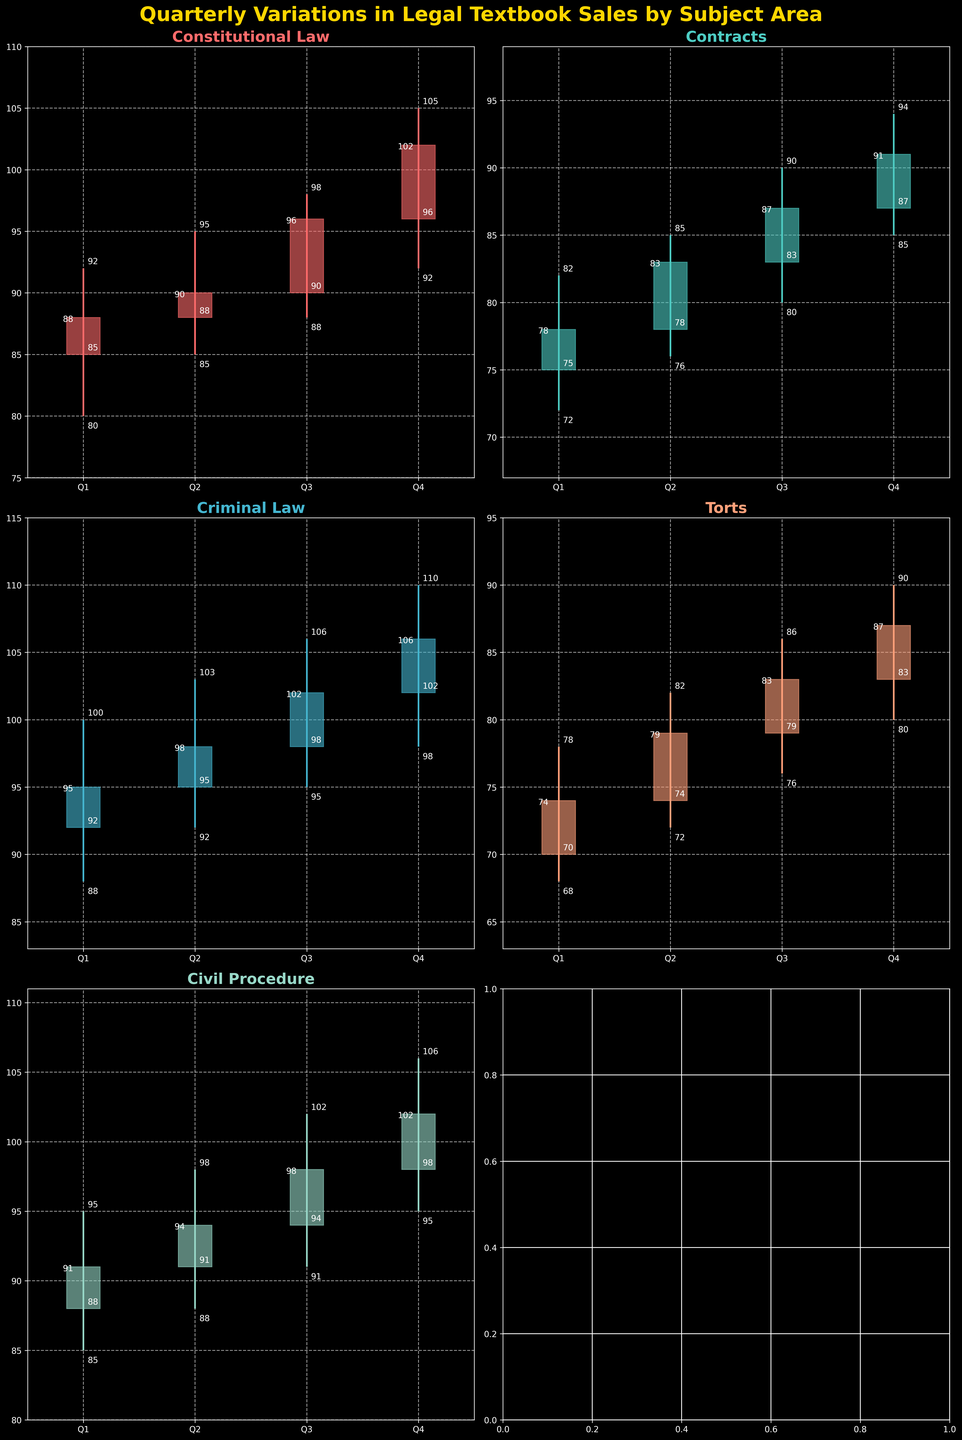Which subject area experienced the highest sales in Q4? The highest sales in Q4 can be identified by looking at the 'Close' values for each subject in Q4. The values are: Constitutional Law (102), Contracts (91), Criminal Law (106), Torts (87), Civil Procedure (102). The highest value is 106 for Criminal Law.
Answer: Criminal Law What was the lowest sales figure for Contracts throughout the year? The lowest sales figure for Contracts can be found by looking at the 'Low' values for each quarter. The values are: Q1 (72), Q2 (76), Q3 (80), Q4 (85). The lowest value is 72 in Q1.
Answer: 72 How did Constitutional Law's sales trend from Q1 to Q4? To understand the trend, observe the 'Close' values for each quarter: Q1 (88), Q2 (90), Q3 (96), Q4 (102). The sales gradually increased from Q1 to Q4.
Answer: Increased Which subject showed the greatest volatility in Q3, based on the difference between High and Low values? Volatility can be measured by the difference between 'High' and 'Low' values in Q3: Constitutional Law (98-88=10), Contracts (90-80=10), Criminal Law (106-95=11), Torts (86-76=10), Civil Procedure (102-91=11). Criminal Law and Civil Procedure both have a difference of 11, which is the highest.
Answer: Criminal Law and Civil Procedure Compare the sales between Torts and Civil Procedure in Q1. Which had higher closing sales? Check the 'Close' values for Q1: Torts (74) and Civil Procedure (91). Civil Procedure had higher closing sales.
Answer: Civil Procedure What was the average closing sales for Criminal Law over the year? To find the average, sum the 'Close' values for each quarter and divide by the number of quarters: (95 + 98 + 102 + 106) / 4 = 100.25.
Answer: 100.25 During which quarter did Contracts see the highest sales figure? Look for the highest 'High' value for Contracts: Q1 (82), Q2 (85), Q3 (90), Q4 (94). The highest value is 94 in Q4.
Answer: Q4 For Torts, what's the difference between the opening sales in Q1 and the closing sales in Q4? To find the difference, subtract the Q1 'Open' value from the Q4 'Close' value: 87 - 70 = 17.
Answer: 17 Did any subject see a decrease in sales from Q3 to Q4? Check the 'Close' values from Q3 and Q4 for each subject: Constitutional Law (96 to 102), Contracts (87 to 91), Criminal Law (102 to 106), Torts (83 to 87), Civil Procedure (98 to 102). None of them saw a decrease.
Answer: No What is the range of sales figures for Civil Procedure in Q2? The range is the difference between the 'High' and 'Low' values in Q2: 98 - 88 = 10.
Answer: 10 